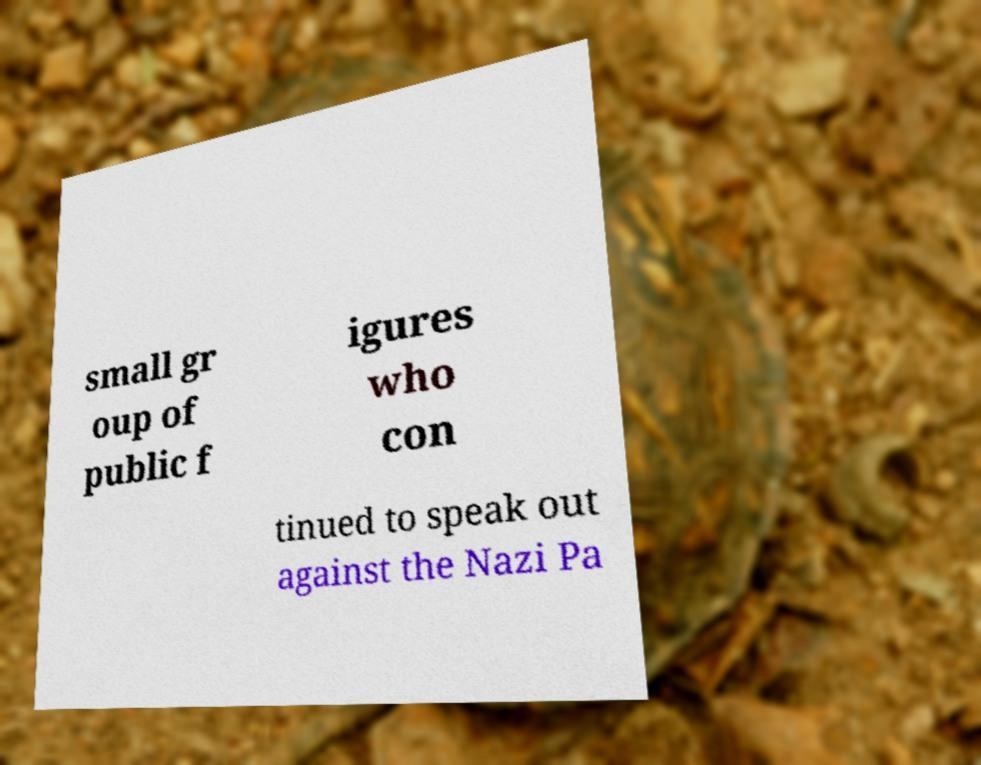Please identify and transcribe the text found in this image. small gr oup of public f igures who con tinued to speak out against the Nazi Pa 